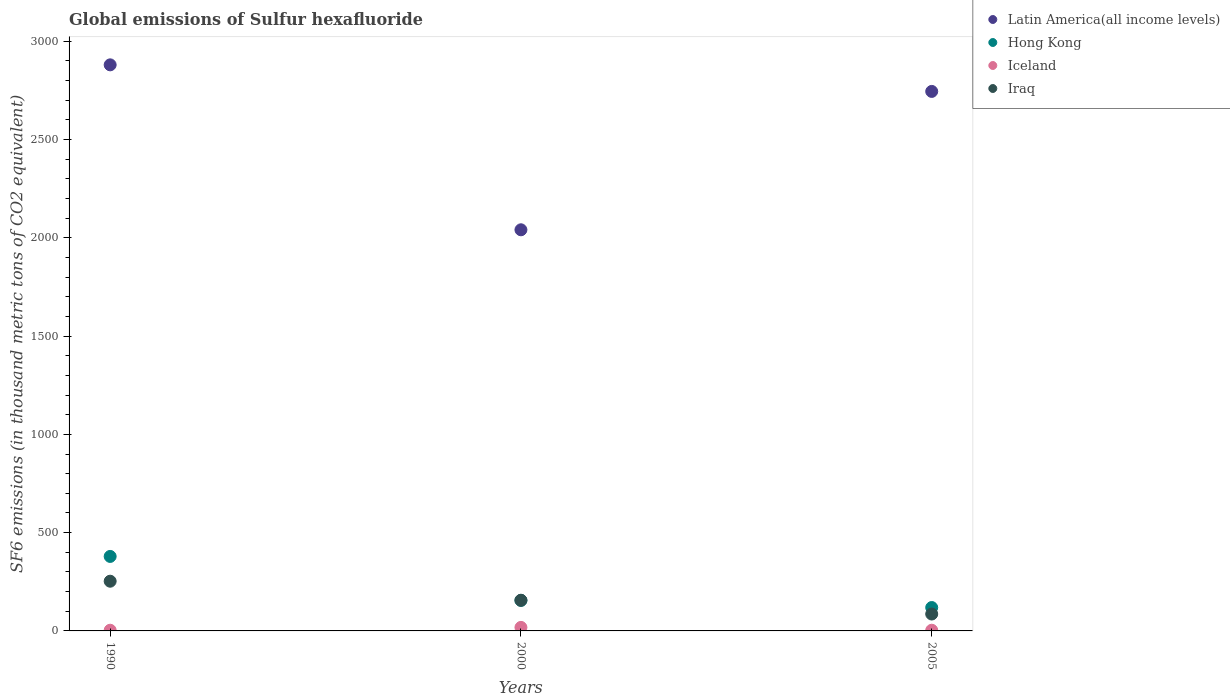Is the number of dotlines equal to the number of legend labels?
Your response must be concise. Yes. Across all years, what is the maximum global emissions of Sulfur hexafluoride in Latin America(all income levels)?
Keep it short and to the point. 2880. Across all years, what is the minimum global emissions of Sulfur hexafluoride in Iraq?
Ensure brevity in your answer.  86. In which year was the global emissions of Sulfur hexafluoride in Iceland maximum?
Offer a very short reply. 2000. In which year was the global emissions of Sulfur hexafluoride in Hong Kong minimum?
Ensure brevity in your answer.  2005. What is the total global emissions of Sulfur hexafluoride in Iraq in the graph?
Ensure brevity in your answer.  495. What is the difference between the global emissions of Sulfur hexafluoride in Iceland in 2000 and that in 2005?
Your answer should be compact. 14.4. What is the difference between the global emissions of Sulfur hexafluoride in Hong Kong in 2000 and the global emissions of Sulfur hexafluoride in Iceland in 1990?
Your response must be concise. 151.8. What is the average global emissions of Sulfur hexafluoride in Latin America(all income levels) per year?
Your response must be concise. 2555.2. In the year 2005, what is the difference between the global emissions of Sulfur hexafluoride in Latin America(all income levels) and global emissions of Sulfur hexafluoride in Iceland?
Your answer should be very brief. 2741.29. In how many years, is the global emissions of Sulfur hexafluoride in Iceland greater than 2600 thousand metric tons?
Make the answer very short. 0. What is the ratio of the global emissions of Sulfur hexafluoride in Iraq in 1990 to that in 2000?
Keep it short and to the point. 1.62. Is the global emissions of Sulfur hexafluoride in Iraq in 1990 less than that in 2005?
Keep it short and to the point. No. What is the difference between the highest and the second highest global emissions of Sulfur hexafluoride in Latin America(all income levels)?
Ensure brevity in your answer.  135.21. What is the difference between the highest and the lowest global emissions of Sulfur hexafluoride in Iceland?
Provide a short and direct response. 14.4. In how many years, is the global emissions of Sulfur hexafluoride in Latin America(all income levels) greater than the average global emissions of Sulfur hexafluoride in Latin America(all income levels) taken over all years?
Offer a terse response. 2. Is the sum of the global emissions of Sulfur hexafluoride in Hong Kong in 2000 and 2005 greater than the maximum global emissions of Sulfur hexafluoride in Iceland across all years?
Keep it short and to the point. Yes. Is it the case that in every year, the sum of the global emissions of Sulfur hexafluoride in Iraq and global emissions of Sulfur hexafluoride in Iceland  is greater than the global emissions of Sulfur hexafluoride in Hong Kong?
Provide a short and direct response. No. Is the global emissions of Sulfur hexafluoride in Iraq strictly greater than the global emissions of Sulfur hexafluoride in Hong Kong over the years?
Your response must be concise. No. Is the global emissions of Sulfur hexafluoride in Iceland strictly less than the global emissions of Sulfur hexafluoride in Latin America(all income levels) over the years?
Offer a terse response. Yes. How many years are there in the graph?
Offer a very short reply. 3. What is the difference between two consecutive major ticks on the Y-axis?
Give a very brief answer. 500. Where does the legend appear in the graph?
Make the answer very short. Top right. What is the title of the graph?
Make the answer very short. Global emissions of Sulfur hexafluoride. What is the label or title of the Y-axis?
Make the answer very short. SF6 emissions (in thousand metric tons of CO2 equivalent). What is the SF6 emissions (in thousand metric tons of CO2 equivalent) of Latin America(all income levels) in 1990?
Keep it short and to the point. 2880. What is the SF6 emissions (in thousand metric tons of CO2 equivalent) in Hong Kong in 1990?
Your answer should be compact. 379. What is the SF6 emissions (in thousand metric tons of CO2 equivalent) in Iraq in 1990?
Your response must be concise. 252.9. What is the SF6 emissions (in thousand metric tons of CO2 equivalent) of Latin America(all income levels) in 2000?
Offer a very short reply. 2040.8. What is the SF6 emissions (in thousand metric tons of CO2 equivalent) in Hong Kong in 2000?
Offer a terse response. 155.3. What is the SF6 emissions (in thousand metric tons of CO2 equivalent) in Iraq in 2000?
Make the answer very short. 156.1. What is the SF6 emissions (in thousand metric tons of CO2 equivalent) of Latin America(all income levels) in 2005?
Keep it short and to the point. 2744.79. What is the SF6 emissions (in thousand metric tons of CO2 equivalent) in Hong Kong in 2005?
Provide a succinct answer. 119. What is the SF6 emissions (in thousand metric tons of CO2 equivalent) of Iraq in 2005?
Provide a short and direct response. 86. Across all years, what is the maximum SF6 emissions (in thousand metric tons of CO2 equivalent) in Latin America(all income levels)?
Your answer should be very brief. 2880. Across all years, what is the maximum SF6 emissions (in thousand metric tons of CO2 equivalent) in Hong Kong?
Ensure brevity in your answer.  379. Across all years, what is the maximum SF6 emissions (in thousand metric tons of CO2 equivalent) of Iceland?
Ensure brevity in your answer.  17.9. Across all years, what is the maximum SF6 emissions (in thousand metric tons of CO2 equivalent) of Iraq?
Provide a succinct answer. 252.9. Across all years, what is the minimum SF6 emissions (in thousand metric tons of CO2 equivalent) of Latin America(all income levels)?
Your answer should be compact. 2040.8. Across all years, what is the minimum SF6 emissions (in thousand metric tons of CO2 equivalent) of Hong Kong?
Ensure brevity in your answer.  119. Across all years, what is the minimum SF6 emissions (in thousand metric tons of CO2 equivalent) of Iraq?
Give a very brief answer. 86. What is the total SF6 emissions (in thousand metric tons of CO2 equivalent) of Latin America(all income levels) in the graph?
Provide a short and direct response. 7665.59. What is the total SF6 emissions (in thousand metric tons of CO2 equivalent) in Hong Kong in the graph?
Your response must be concise. 653.3. What is the total SF6 emissions (in thousand metric tons of CO2 equivalent) of Iceland in the graph?
Ensure brevity in your answer.  24.9. What is the total SF6 emissions (in thousand metric tons of CO2 equivalent) in Iraq in the graph?
Offer a terse response. 495. What is the difference between the SF6 emissions (in thousand metric tons of CO2 equivalent) of Latin America(all income levels) in 1990 and that in 2000?
Offer a terse response. 839.2. What is the difference between the SF6 emissions (in thousand metric tons of CO2 equivalent) of Hong Kong in 1990 and that in 2000?
Your answer should be very brief. 223.7. What is the difference between the SF6 emissions (in thousand metric tons of CO2 equivalent) of Iceland in 1990 and that in 2000?
Your answer should be compact. -14.4. What is the difference between the SF6 emissions (in thousand metric tons of CO2 equivalent) in Iraq in 1990 and that in 2000?
Provide a short and direct response. 96.8. What is the difference between the SF6 emissions (in thousand metric tons of CO2 equivalent) in Latin America(all income levels) in 1990 and that in 2005?
Offer a terse response. 135.21. What is the difference between the SF6 emissions (in thousand metric tons of CO2 equivalent) in Hong Kong in 1990 and that in 2005?
Offer a very short reply. 260. What is the difference between the SF6 emissions (in thousand metric tons of CO2 equivalent) in Iceland in 1990 and that in 2005?
Give a very brief answer. 0. What is the difference between the SF6 emissions (in thousand metric tons of CO2 equivalent) in Iraq in 1990 and that in 2005?
Offer a terse response. 166.9. What is the difference between the SF6 emissions (in thousand metric tons of CO2 equivalent) of Latin America(all income levels) in 2000 and that in 2005?
Your answer should be compact. -703.99. What is the difference between the SF6 emissions (in thousand metric tons of CO2 equivalent) of Hong Kong in 2000 and that in 2005?
Provide a short and direct response. 36.3. What is the difference between the SF6 emissions (in thousand metric tons of CO2 equivalent) of Iceland in 2000 and that in 2005?
Your answer should be compact. 14.4. What is the difference between the SF6 emissions (in thousand metric tons of CO2 equivalent) in Iraq in 2000 and that in 2005?
Your response must be concise. 70.1. What is the difference between the SF6 emissions (in thousand metric tons of CO2 equivalent) in Latin America(all income levels) in 1990 and the SF6 emissions (in thousand metric tons of CO2 equivalent) in Hong Kong in 2000?
Make the answer very short. 2724.7. What is the difference between the SF6 emissions (in thousand metric tons of CO2 equivalent) in Latin America(all income levels) in 1990 and the SF6 emissions (in thousand metric tons of CO2 equivalent) in Iceland in 2000?
Make the answer very short. 2862.1. What is the difference between the SF6 emissions (in thousand metric tons of CO2 equivalent) of Latin America(all income levels) in 1990 and the SF6 emissions (in thousand metric tons of CO2 equivalent) of Iraq in 2000?
Keep it short and to the point. 2723.9. What is the difference between the SF6 emissions (in thousand metric tons of CO2 equivalent) of Hong Kong in 1990 and the SF6 emissions (in thousand metric tons of CO2 equivalent) of Iceland in 2000?
Your answer should be very brief. 361.1. What is the difference between the SF6 emissions (in thousand metric tons of CO2 equivalent) of Hong Kong in 1990 and the SF6 emissions (in thousand metric tons of CO2 equivalent) of Iraq in 2000?
Keep it short and to the point. 222.9. What is the difference between the SF6 emissions (in thousand metric tons of CO2 equivalent) of Iceland in 1990 and the SF6 emissions (in thousand metric tons of CO2 equivalent) of Iraq in 2000?
Provide a short and direct response. -152.6. What is the difference between the SF6 emissions (in thousand metric tons of CO2 equivalent) in Latin America(all income levels) in 1990 and the SF6 emissions (in thousand metric tons of CO2 equivalent) in Hong Kong in 2005?
Offer a very short reply. 2761. What is the difference between the SF6 emissions (in thousand metric tons of CO2 equivalent) in Latin America(all income levels) in 1990 and the SF6 emissions (in thousand metric tons of CO2 equivalent) in Iceland in 2005?
Your answer should be compact. 2876.5. What is the difference between the SF6 emissions (in thousand metric tons of CO2 equivalent) of Latin America(all income levels) in 1990 and the SF6 emissions (in thousand metric tons of CO2 equivalent) of Iraq in 2005?
Offer a very short reply. 2794. What is the difference between the SF6 emissions (in thousand metric tons of CO2 equivalent) in Hong Kong in 1990 and the SF6 emissions (in thousand metric tons of CO2 equivalent) in Iceland in 2005?
Your response must be concise. 375.5. What is the difference between the SF6 emissions (in thousand metric tons of CO2 equivalent) in Hong Kong in 1990 and the SF6 emissions (in thousand metric tons of CO2 equivalent) in Iraq in 2005?
Your response must be concise. 293. What is the difference between the SF6 emissions (in thousand metric tons of CO2 equivalent) in Iceland in 1990 and the SF6 emissions (in thousand metric tons of CO2 equivalent) in Iraq in 2005?
Keep it short and to the point. -82.5. What is the difference between the SF6 emissions (in thousand metric tons of CO2 equivalent) of Latin America(all income levels) in 2000 and the SF6 emissions (in thousand metric tons of CO2 equivalent) of Hong Kong in 2005?
Provide a short and direct response. 1921.8. What is the difference between the SF6 emissions (in thousand metric tons of CO2 equivalent) in Latin America(all income levels) in 2000 and the SF6 emissions (in thousand metric tons of CO2 equivalent) in Iceland in 2005?
Offer a terse response. 2037.3. What is the difference between the SF6 emissions (in thousand metric tons of CO2 equivalent) in Latin America(all income levels) in 2000 and the SF6 emissions (in thousand metric tons of CO2 equivalent) in Iraq in 2005?
Provide a short and direct response. 1954.8. What is the difference between the SF6 emissions (in thousand metric tons of CO2 equivalent) in Hong Kong in 2000 and the SF6 emissions (in thousand metric tons of CO2 equivalent) in Iceland in 2005?
Your answer should be compact. 151.8. What is the difference between the SF6 emissions (in thousand metric tons of CO2 equivalent) of Hong Kong in 2000 and the SF6 emissions (in thousand metric tons of CO2 equivalent) of Iraq in 2005?
Provide a short and direct response. 69.3. What is the difference between the SF6 emissions (in thousand metric tons of CO2 equivalent) of Iceland in 2000 and the SF6 emissions (in thousand metric tons of CO2 equivalent) of Iraq in 2005?
Ensure brevity in your answer.  -68.1. What is the average SF6 emissions (in thousand metric tons of CO2 equivalent) in Latin America(all income levels) per year?
Provide a short and direct response. 2555.2. What is the average SF6 emissions (in thousand metric tons of CO2 equivalent) of Hong Kong per year?
Provide a short and direct response. 217.77. What is the average SF6 emissions (in thousand metric tons of CO2 equivalent) of Iceland per year?
Offer a terse response. 8.3. What is the average SF6 emissions (in thousand metric tons of CO2 equivalent) of Iraq per year?
Provide a short and direct response. 165. In the year 1990, what is the difference between the SF6 emissions (in thousand metric tons of CO2 equivalent) in Latin America(all income levels) and SF6 emissions (in thousand metric tons of CO2 equivalent) in Hong Kong?
Provide a short and direct response. 2501. In the year 1990, what is the difference between the SF6 emissions (in thousand metric tons of CO2 equivalent) of Latin America(all income levels) and SF6 emissions (in thousand metric tons of CO2 equivalent) of Iceland?
Offer a very short reply. 2876.5. In the year 1990, what is the difference between the SF6 emissions (in thousand metric tons of CO2 equivalent) in Latin America(all income levels) and SF6 emissions (in thousand metric tons of CO2 equivalent) in Iraq?
Your answer should be compact. 2627.1. In the year 1990, what is the difference between the SF6 emissions (in thousand metric tons of CO2 equivalent) of Hong Kong and SF6 emissions (in thousand metric tons of CO2 equivalent) of Iceland?
Offer a very short reply. 375.5. In the year 1990, what is the difference between the SF6 emissions (in thousand metric tons of CO2 equivalent) of Hong Kong and SF6 emissions (in thousand metric tons of CO2 equivalent) of Iraq?
Provide a succinct answer. 126.1. In the year 1990, what is the difference between the SF6 emissions (in thousand metric tons of CO2 equivalent) of Iceland and SF6 emissions (in thousand metric tons of CO2 equivalent) of Iraq?
Make the answer very short. -249.4. In the year 2000, what is the difference between the SF6 emissions (in thousand metric tons of CO2 equivalent) in Latin America(all income levels) and SF6 emissions (in thousand metric tons of CO2 equivalent) in Hong Kong?
Ensure brevity in your answer.  1885.5. In the year 2000, what is the difference between the SF6 emissions (in thousand metric tons of CO2 equivalent) of Latin America(all income levels) and SF6 emissions (in thousand metric tons of CO2 equivalent) of Iceland?
Offer a terse response. 2022.9. In the year 2000, what is the difference between the SF6 emissions (in thousand metric tons of CO2 equivalent) in Latin America(all income levels) and SF6 emissions (in thousand metric tons of CO2 equivalent) in Iraq?
Your answer should be very brief. 1884.7. In the year 2000, what is the difference between the SF6 emissions (in thousand metric tons of CO2 equivalent) in Hong Kong and SF6 emissions (in thousand metric tons of CO2 equivalent) in Iceland?
Make the answer very short. 137.4. In the year 2000, what is the difference between the SF6 emissions (in thousand metric tons of CO2 equivalent) of Hong Kong and SF6 emissions (in thousand metric tons of CO2 equivalent) of Iraq?
Your response must be concise. -0.8. In the year 2000, what is the difference between the SF6 emissions (in thousand metric tons of CO2 equivalent) of Iceland and SF6 emissions (in thousand metric tons of CO2 equivalent) of Iraq?
Provide a short and direct response. -138.2. In the year 2005, what is the difference between the SF6 emissions (in thousand metric tons of CO2 equivalent) in Latin America(all income levels) and SF6 emissions (in thousand metric tons of CO2 equivalent) in Hong Kong?
Your answer should be very brief. 2625.79. In the year 2005, what is the difference between the SF6 emissions (in thousand metric tons of CO2 equivalent) of Latin America(all income levels) and SF6 emissions (in thousand metric tons of CO2 equivalent) of Iceland?
Give a very brief answer. 2741.29. In the year 2005, what is the difference between the SF6 emissions (in thousand metric tons of CO2 equivalent) of Latin America(all income levels) and SF6 emissions (in thousand metric tons of CO2 equivalent) of Iraq?
Keep it short and to the point. 2658.79. In the year 2005, what is the difference between the SF6 emissions (in thousand metric tons of CO2 equivalent) of Hong Kong and SF6 emissions (in thousand metric tons of CO2 equivalent) of Iceland?
Your response must be concise. 115.5. In the year 2005, what is the difference between the SF6 emissions (in thousand metric tons of CO2 equivalent) of Hong Kong and SF6 emissions (in thousand metric tons of CO2 equivalent) of Iraq?
Your answer should be compact. 33. In the year 2005, what is the difference between the SF6 emissions (in thousand metric tons of CO2 equivalent) of Iceland and SF6 emissions (in thousand metric tons of CO2 equivalent) of Iraq?
Your answer should be very brief. -82.5. What is the ratio of the SF6 emissions (in thousand metric tons of CO2 equivalent) of Latin America(all income levels) in 1990 to that in 2000?
Provide a succinct answer. 1.41. What is the ratio of the SF6 emissions (in thousand metric tons of CO2 equivalent) of Hong Kong in 1990 to that in 2000?
Keep it short and to the point. 2.44. What is the ratio of the SF6 emissions (in thousand metric tons of CO2 equivalent) of Iceland in 1990 to that in 2000?
Ensure brevity in your answer.  0.2. What is the ratio of the SF6 emissions (in thousand metric tons of CO2 equivalent) in Iraq in 1990 to that in 2000?
Your answer should be very brief. 1.62. What is the ratio of the SF6 emissions (in thousand metric tons of CO2 equivalent) in Latin America(all income levels) in 1990 to that in 2005?
Ensure brevity in your answer.  1.05. What is the ratio of the SF6 emissions (in thousand metric tons of CO2 equivalent) of Hong Kong in 1990 to that in 2005?
Ensure brevity in your answer.  3.18. What is the ratio of the SF6 emissions (in thousand metric tons of CO2 equivalent) of Iceland in 1990 to that in 2005?
Make the answer very short. 1. What is the ratio of the SF6 emissions (in thousand metric tons of CO2 equivalent) in Iraq in 1990 to that in 2005?
Offer a terse response. 2.94. What is the ratio of the SF6 emissions (in thousand metric tons of CO2 equivalent) in Latin America(all income levels) in 2000 to that in 2005?
Offer a very short reply. 0.74. What is the ratio of the SF6 emissions (in thousand metric tons of CO2 equivalent) of Hong Kong in 2000 to that in 2005?
Give a very brief answer. 1.3. What is the ratio of the SF6 emissions (in thousand metric tons of CO2 equivalent) in Iceland in 2000 to that in 2005?
Provide a short and direct response. 5.11. What is the ratio of the SF6 emissions (in thousand metric tons of CO2 equivalent) in Iraq in 2000 to that in 2005?
Offer a terse response. 1.82. What is the difference between the highest and the second highest SF6 emissions (in thousand metric tons of CO2 equivalent) in Latin America(all income levels)?
Give a very brief answer. 135.21. What is the difference between the highest and the second highest SF6 emissions (in thousand metric tons of CO2 equivalent) in Hong Kong?
Your answer should be compact. 223.7. What is the difference between the highest and the second highest SF6 emissions (in thousand metric tons of CO2 equivalent) of Iraq?
Your answer should be compact. 96.8. What is the difference between the highest and the lowest SF6 emissions (in thousand metric tons of CO2 equivalent) of Latin America(all income levels)?
Offer a very short reply. 839.2. What is the difference between the highest and the lowest SF6 emissions (in thousand metric tons of CO2 equivalent) of Hong Kong?
Offer a terse response. 260. What is the difference between the highest and the lowest SF6 emissions (in thousand metric tons of CO2 equivalent) of Iraq?
Your response must be concise. 166.9. 